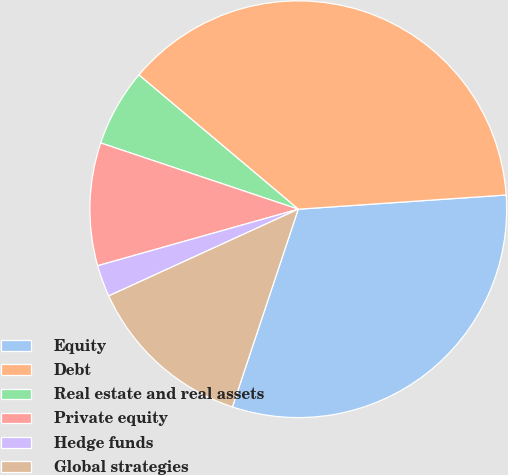Convert chart. <chart><loc_0><loc_0><loc_500><loc_500><pie_chart><fcel>Equity<fcel>Debt<fcel>Real estate and real assets<fcel>Private equity<fcel>Hedge funds<fcel>Global strategies<nl><fcel>31.2%<fcel>37.77%<fcel>5.99%<fcel>9.52%<fcel>2.46%<fcel>13.05%<nl></chart> 